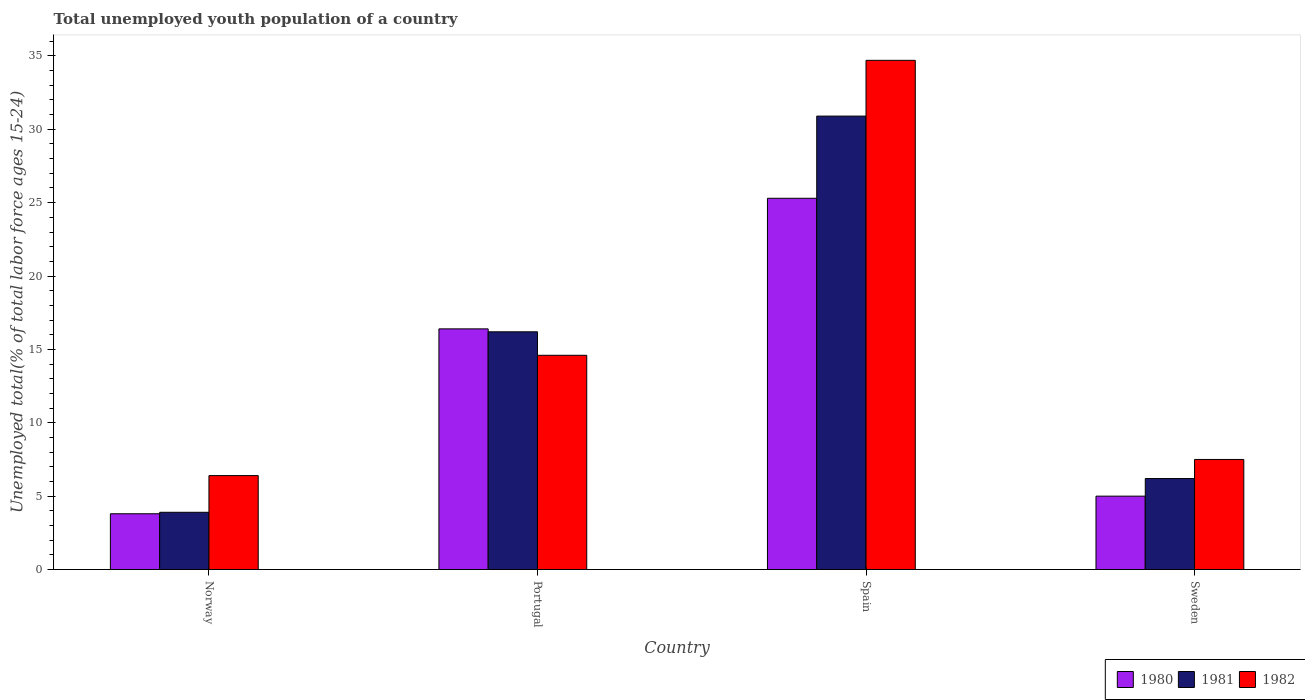How many groups of bars are there?
Keep it short and to the point. 4. How many bars are there on the 1st tick from the left?
Ensure brevity in your answer.  3. How many bars are there on the 4th tick from the right?
Your answer should be very brief. 3. What is the percentage of total unemployed youth population of a country in 1981 in Spain?
Keep it short and to the point. 30.9. Across all countries, what is the maximum percentage of total unemployed youth population of a country in 1981?
Offer a terse response. 30.9. Across all countries, what is the minimum percentage of total unemployed youth population of a country in 1982?
Give a very brief answer. 6.4. In which country was the percentage of total unemployed youth population of a country in 1981 maximum?
Make the answer very short. Spain. In which country was the percentage of total unemployed youth population of a country in 1982 minimum?
Your response must be concise. Norway. What is the total percentage of total unemployed youth population of a country in 1980 in the graph?
Give a very brief answer. 50.5. What is the difference between the percentage of total unemployed youth population of a country in 1980 in Spain and that in Sweden?
Keep it short and to the point. 20.3. What is the difference between the percentage of total unemployed youth population of a country in 1980 in Sweden and the percentage of total unemployed youth population of a country in 1981 in Norway?
Offer a very short reply. 1.1. What is the average percentage of total unemployed youth population of a country in 1981 per country?
Provide a short and direct response. 14.3. What is the difference between the percentage of total unemployed youth population of a country of/in 1980 and percentage of total unemployed youth population of a country of/in 1981 in Sweden?
Your answer should be compact. -1.2. In how many countries, is the percentage of total unemployed youth population of a country in 1982 greater than 29 %?
Your response must be concise. 1. What is the ratio of the percentage of total unemployed youth population of a country in 1981 in Norway to that in Sweden?
Offer a very short reply. 0.63. Is the difference between the percentage of total unemployed youth population of a country in 1980 in Spain and Sweden greater than the difference between the percentage of total unemployed youth population of a country in 1981 in Spain and Sweden?
Your response must be concise. No. What is the difference between the highest and the second highest percentage of total unemployed youth population of a country in 1982?
Your response must be concise. 20.1. What is the difference between the highest and the lowest percentage of total unemployed youth population of a country in 1982?
Keep it short and to the point. 28.3. Is the sum of the percentage of total unemployed youth population of a country in 1982 in Norway and Portugal greater than the maximum percentage of total unemployed youth population of a country in 1981 across all countries?
Keep it short and to the point. No. What does the 3rd bar from the right in Sweden represents?
Make the answer very short. 1980. Is it the case that in every country, the sum of the percentage of total unemployed youth population of a country in 1981 and percentage of total unemployed youth population of a country in 1980 is greater than the percentage of total unemployed youth population of a country in 1982?
Your response must be concise. Yes. How many bars are there?
Provide a succinct answer. 12. How many countries are there in the graph?
Offer a terse response. 4. What is the difference between two consecutive major ticks on the Y-axis?
Provide a short and direct response. 5. Where does the legend appear in the graph?
Provide a succinct answer. Bottom right. How are the legend labels stacked?
Your answer should be very brief. Horizontal. What is the title of the graph?
Provide a succinct answer. Total unemployed youth population of a country. Does "2014" appear as one of the legend labels in the graph?
Give a very brief answer. No. What is the label or title of the Y-axis?
Offer a terse response. Unemployed total(% of total labor force ages 15-24). What is the Unemployed total(% of total labor force ages 15-24) of 1980 in Norway?
Keep it short and to the point. 3.8. What is the Unemployed total(% of total labor force ages 15-24) in 1981 in Norway?
Offer a terse response. 3.9. What is the Unemployed total(% of total labor force ages 15-24) in 1982 in Norway?
Make the answer very short. 6.4. What is the Unemployed total(% of total labor force ages 15-24) of 1980 in Portugal?
Ensure brevity in your answer.  16.4. What is the Unemployed total(% of total labor force ages 15-24) in 1981 in Portugal?
Ensure brevity in your answer.  16.2. What is the Unemployed total(% of total labor force ages 15-24) in 1982 in Portugal?
Make the answer very short. 14.6. What is the Unemployed total(% of total labor force ages 15-24) in 1980 in Spain?
Give a very brief answer. 25.3. What is the Unemployed total(% of total labor force ages 15-24) of 1981 in Spain?
Offer a terse response. 30.9. What is the Unemployed total(% of total labor force ages 15-24) of 1982 in Spain?
Your answer should be very brief. 34.7. What is the Unemployed total(% of total labor force ages 15-24) in 1981 in Sweden?
Keep it short and to the point. 6.2. Across all countries, what is the maximum Unemployed total(% of total labor force ages 15-24) of 1980?
Your answer should be very brief. 25.3. Across all countries, what is the maximum Unemployed total(% of total labor force ages 15-24) in 1981?
Offer a terse response. 30.9. Across all countries, what is the maximum Unemployed total(% of total labor force ages 15-24) of 1982?
Provide a short and direct response. 34.7. Across all countries, what is the minimum Unemployed total(% of total labor force ages 15-24) in 1980?
Ensure brevity in your answer.  3.8. Across all countries, what is the minimum Unemployed total(% of total labor force ages 15-24) in 1981?
Provide a succinct answer. 3.9. Across all countries, what is the minimum Unemployed total(% of total labor force ages 15-24) in 1982?
Offer a terse response. 6.4. What is the total Unemployed total(% of total labor force ages 15-24) of 1980 in the graph?
Ensure brevity in your answer.  50.5. What is the total Unemployed total(% of total labor force ages 15-24) in 1981 in the graph?
Your response must be concise. 57.2. What is the total Unemployed total(% of total labor force ages 15-24) of 1982 in the graph?
Your answer should be very brief. 63.2. What is the difference between the Unemployed total(% of total labor force ages 15-24) in 1980 in Norway and that in Portugal?
Your answer should be very brief. -12.6. What is the difference between the Unemployed total(% of total labor force ages 15-24) in 1982 in Norway and that in Portugal?
Your response must be concise. -8.2. What is the difference between the Unemployed total(% of total labor force ages 15-24) of 1980 in Norway and that in Spain?
Your answer should be compact. -21.5. What is the difference between the Unemployed total(% of total labor force ages 15-24) in 1982 in Norway and that in Spain?
Your response must be concise. -28.3. What is the difference between the Unemployed total(% of total labor force ages 15-24) of 1980 in Norway and that in Sweden?
Provide a short and direct response. -1.2. What is the difference between the Unemployed total(% of total labor force ages 15-24) of 1981 in Norway and that in Sweden?
Ensure brevity in your answer.  -2.3. What is the difference between the Unemployed total(% of total labor force ages 15-24) of 1982 in Norway and that in Sweden?
Offer a very short reply. -1.1. What is the difference between the Unemployed total(% of total labor force ages 15-24) of 1980 in Portugal and that in Spain?
Your answer should be compact. -8.9. What is the difference between the Unemployed total(% of total labor force ages 15-24) of 1981 in Portugal and that in Spain?
Keep it short and to the point. -14.7. What is the difference between the Unemployed total(% of total labor force ages 15-24) of 1982 in Portugal and that in Spain?
Make the answer very short. -20.1. What is the difference between the Unemployed total(% of total labor force ages 15-24) of 1980 in Portugal and that in Sweden?
Offer a terse response. 11.4. What is the difference between the Unemployed total(% of total labor force ages 15-24) in 1981 in Portugal and that in Sweden?
Keep it short and to the point. 10. What is the difference between the Unemployed total(% of total labor force ages 15-24) of 1980 in Spain and that in Sweden?
Keep it short and to the point. 20.3. What is the difference between the Unemployed total(% of total labor force ages 15-24) in 1981 in Spain and that in Sweden?
Give a very brief answer. 24.7. What is the difference between the Unemployed total(% of total labor force ages 15-24) of 1982 in Spain and that in Sweden?
Give a very brief answer. 27.2. What is the difference between the Unemployed total(% of total labor force ages 15-24) of 1980 in Norway and the Unemployed total(% of total labor force ages 15-24) of 1981 in Portugal?
Offer a terse response. -12.4. What is the difference between the Unemployed total(% of total labor force ages 15-24) in 1981 in Norway and the Unemployed total(% of total labor force ages 15-24) in 1982 in Portugal?
Ensure brevity in your answer.  -10.7. What is the difference between the Unemployed total(% of total labor force ages 15-24) in 1980 in Norway and the Unemployed total(% of total labor force ages 15-24) in 1981 in Spain?
Your answer should be very brief. -27.1. What is the difference between the Unemployed total(% of total labor force ages 15-24) in 1980 in Norway and the Unemployed total(% of total labor force ages 15-24) in 1982 in Spain?
Offer a very short reply. -30.9. What is the difference between the Unemployed total(% of total labor force ages 15-24) in 1981 in Norway and the Unemployed total(% of total labor force ages 15-24) in 1982 in Spain?
Your answer should be very brief. -30.8. What is the difference between the Unemployed total(% of total labor force ages 15-24) of 1980 in Norway and the Unemployed total(% of total labor force ages 15-24) of 1981 in Sweden?
Provide a succinct answer. -2.4. What is the difference between the Unemployed total(% of total labor force ages 15-24) of 1980 in Portugal and the Unemployed total(% of total labor force ages 15-24) of 1982 in Spain?
Your answer should be compact. -18.3. What is the difference between the Unemployed total(% of total labor force ages 15-24) in 1981 in Portugal and the Unemployed total(% of total labor force ages 15-24) in 1982 in Spain?
Offer a very short reply. -18.5. What is the difference between the Unemployed total(% of total labor force ages 15-24) of 1980 in Portugal and the Unemployed total(% of total labor force ages 15-24) of 1982 in Sweden?
Keep it short and to the point. 8.9. What is the difference between the Unemployed total(% of total labor force ages 15-24) of 1980 in Spain and the Unemployed total(% of total labor force ages 15-24) of 1982 in Sweden?
Offer a terse response. 17.8. What is the difference between the Unemployed total(% of total labor force ages 15-24) in 1981 in Spain and the Unemployed total(% of total labor force ages 15-24) in 1982 in Sweden?
Your answer should be very brief. 23.4. What is the average Unemployed total(% of total labor force ages 15-24) of 1980 per country?
Keep it short and to the point. 12.62. What is the average Unemployed total(% of total labor force ages 15-24) in 1981 per country?
Your answer should be very brief. 14.3. What is the average Unemployed total(% of total labor force ages 15-24) of 1982 per country?
Offer a terse response. 15.8. What is the difference between the Unemployed total(% of total labor force ages 15-24) in 1980 and Unemployed total(% of total labor force ages 15-24) in 1981 in Norway?
Offer a very short reply. -0.1. What is the difference between the Unemployed total(% of total labor force ages 15-24) of 1980 and Unemployed total(% of total labor force ages 15-24) of 1982 in Norway?
Offer a very short reply. -2.6. What is the difference between the Unemployed total(% of total labor force ages 15-24) in 1980 and Unemployed total(% of total labor force ages 15-24) in 1981 in Portugal?
Ensure brevity in your answer.  0.2. What is the difference between the Unemployed total(% of total labor force ages 15-24) in 1980 and Unemployed total(% of total labor force ages 15-24) in 1981 in Spain?
Provide a succinct answer. -5.6. What is the difference between the Unemployed total(% of total labor force ages 15-24) of 1980 and Unemployed total(% of total labor force ages 15-24) of 1982 in Sweden?
Your answer should be very brief. -2.5. What is the ratio of the Unemployed total(% of total labor force ages 15-24) of 1980 in Norway to that in Portugal?
Make the answer very short. 0.23. What is the ratio of the Unemployed total(% of total labor force ages 15-24) of 1981 in Norway to that in Portugal?
Ensure brevity in your answer.  0.24. What is the ratio of the Unemployed total(% of total labor force ages 15-24) in 1982 in Norway to that in Portugal?
Provide a short and direct response. 0.44. What is the ratio of the Unemployed total(% of total labor force ages 15-24) in 1980 in Norway to that in Spain?
Make the answer very short. 0.15. What is the ratio of the Unemployed total(% of total labor force ages 15-24) in 1981 in Norway to that in Spain?
Make the answer very short. 0.13. What is the ratio of the Unemployed total(% of total labor force ages 15-24) in 1982 in Norway to that in Spain?
Your answer should be very brief. 0.18. What is the ratio of the Unemployed total(% of total labor force ages 15-24) of 1980 in Norway to that in Sweden?
Give a very brief answer. 0.76. What is the ratio of the Unemployed total(% of total labor force ages 15-24) of 1981 in Norway to that in Sweden?
Your answer should be very brief. 0.63. What is the ratio of the Unemployed total(% of total labor force ages 15-24) in 1982 in Norway to that in Sweden?
Keep it short and to the point. 0.85. What is the ratio of the Unemployed total(% of total labor force ages 15-24) of 1980 in Portugal to that in Spain?
Your response must be concise. 0.65. What is the ratio of the Unemployed total(% of total labor force ages 15-24) of 1981 in Portugal to that in Spain?
Your response must be concise. 0.52. What is the ratio of the Unemployed total(% of total labor force ages 15-24) in 1982 in Portugal to that in Spain?
Give a very brief answer. 0.42. What is the ratio of the Unemployed total(% of total labor force ages 15-24) in 1980 in Portugal to that in Sweden?
Make the answer very short. 3.28. What is the ratio of the Unemployed total(% of total labor force ages 15-24) in 1981 in Portugal to that in Sweden?
Offer a terse response. 2.61. What is the ratio of the Unemployed total(% of total labor force ages 15-24) of 1982 in Portugal to that in Sweden?
Offer a terse response. 1.95. What is the ratio of the Unemployed total(% of total labor force ages 15-24) of 1980 in Spain to that in Sweden?
Ensure brevity in your answer.  5.06. What is the ratio of the Unemployed total(% of total labor force ages 15-24) of 1981 in Spain to that in Sweden?
Keep it short and to the point. 4.98. What is the ratio of the Unemployed total(% of total labor force ages 15-24) in 1982 in Spain to that in Sweden?
Make the answer very short. 4.63. What is the difference between the highest and the second highest Unemployed total(% of total labor force ages 15-24) in 1981?
Offer a terse response. 14.7. What is the difference between the highest and the second highest Unemployed total(% of total labor force ages 15-24) in 1982?
Your response must be concise. 20.1. What is the difference between the highest and the lowest Unemployed total(% of total labor force ages 15-24) of 1980?
Keep it short and to the point. 21.5. What is the difference between the highest and the lowest Unemployed total(% of total labor force ages 15-24) of 1981?
Provide a short and direct response. 27. What is the difference between the highest and the lowest Unemployed total(% of total labor force ages 15-24) of 1982?
Keep it short and to the point. 28.3. 